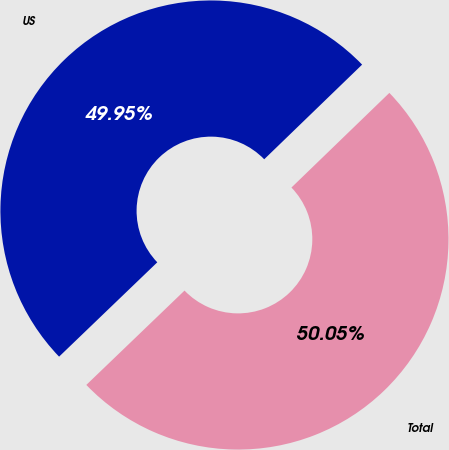<chart> <loc_0><loc_0><loc_500><loc_500><pie_chart><fcel>US<fcel>Total<nl><fcel>49.95%<fcel>50.05%<nl></chart> 